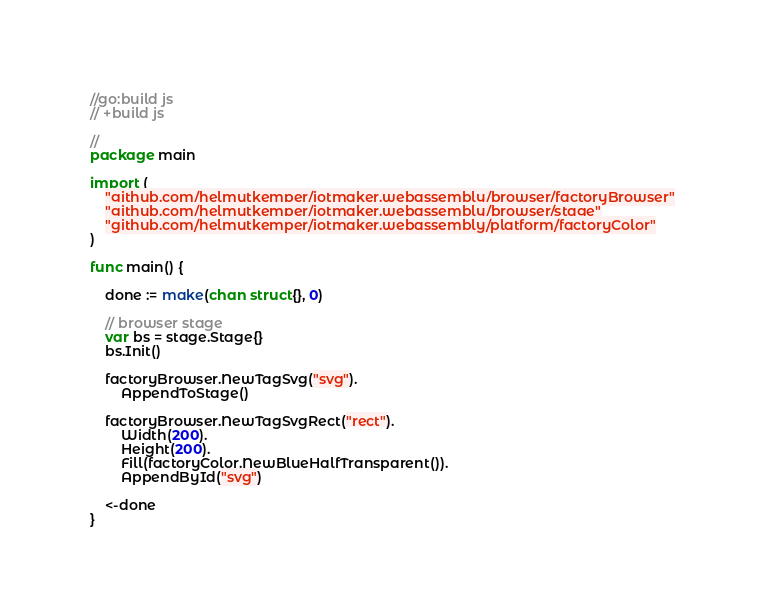<code> <loc_0><loc_0><loc_500><loc_500><_Go_>//go:build js
// +build js

//
package main

import (
	"github.com/helmutkemper/iotmaker.webassembly/browser/factoryBrowser"
	"github.com/helmutkemper/iotmaker.webassembly/browser/stage"
	"github.com/helmutkemper/iotmaker.webassembly/platform/factoryColor"
)

func main() {

	done := make(chan struct{}, 0)

	// browser stage
	var bs = stage.Stage{}
	bs.Init()

	factoryBrowser.NewTagSvg("svg").
		AppendToStage()

	factoryBrowser.NewTagSvgRect("rect").
		Width(200).
		Height(200).
		Fill(factoryColor.NewBlueHalfTransparent()).
		AppendById("svg")

	<-done
}
</code> 